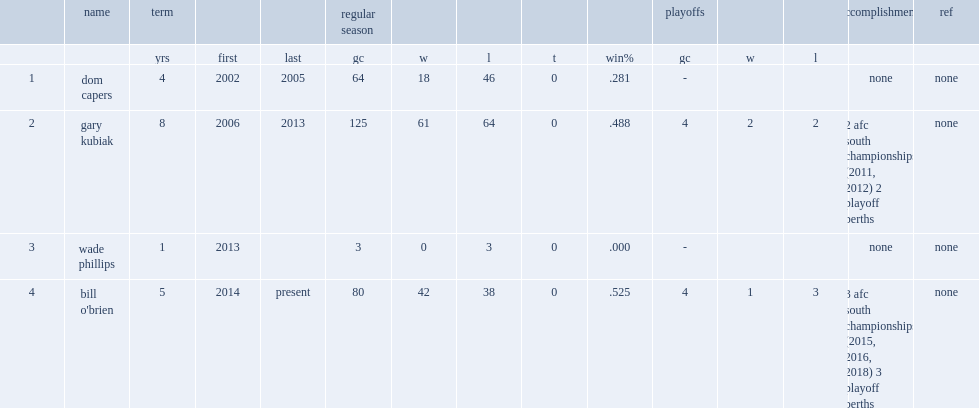Which year of houston texans head coach was bill o'brien? 2014.0. 